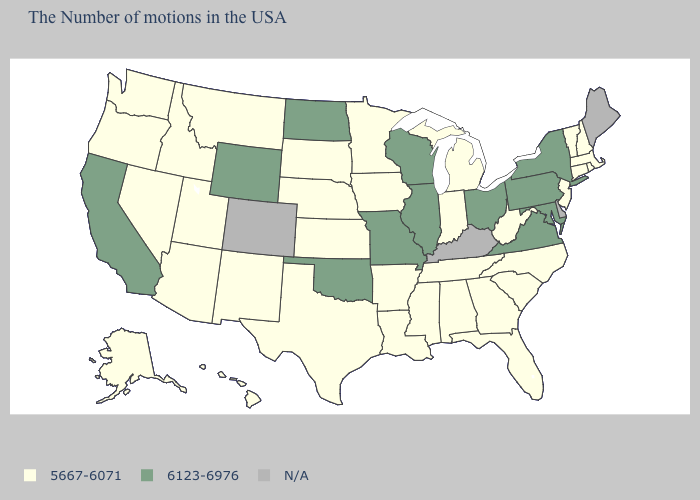Does Virginia have the lowest value in the USA?
Be succinct. No. What is the value of North Dakota?
Concise answer only. 6123-6976. Which states hav the highest value in the MidWest?
Keep it brief. Ohio, Wisconsin, Illinois, Missouri, North Dakota. What is the value of Delaware?
Write a very short answer. N/A. What is the highest value in the MidWest ?
Quick response, please. 6123-6976. Name the states that have a value in the range 6123-6976?
Short answer required. New York, Maryland, Pennsylvania, Virginia, Ohio, Wisconsin, Illinois, Missouri, Oklahoma, North Dakota, Wyoming, California. What is the value of Connecticut?
Give a very brief answer. 5667-6071. Does the map have missing data?
Write a very short answer. Yes. What is the value of Nevada?
Give a very brief answer. 5667-6071. Does New York have the lowest value in the Northeast?
Quick response, please. No. What is the highest value in the USA?
Answer briefly. 6123-6976. Does Hawaii have the lowest value in the USA?
Short answer required. Yes. 